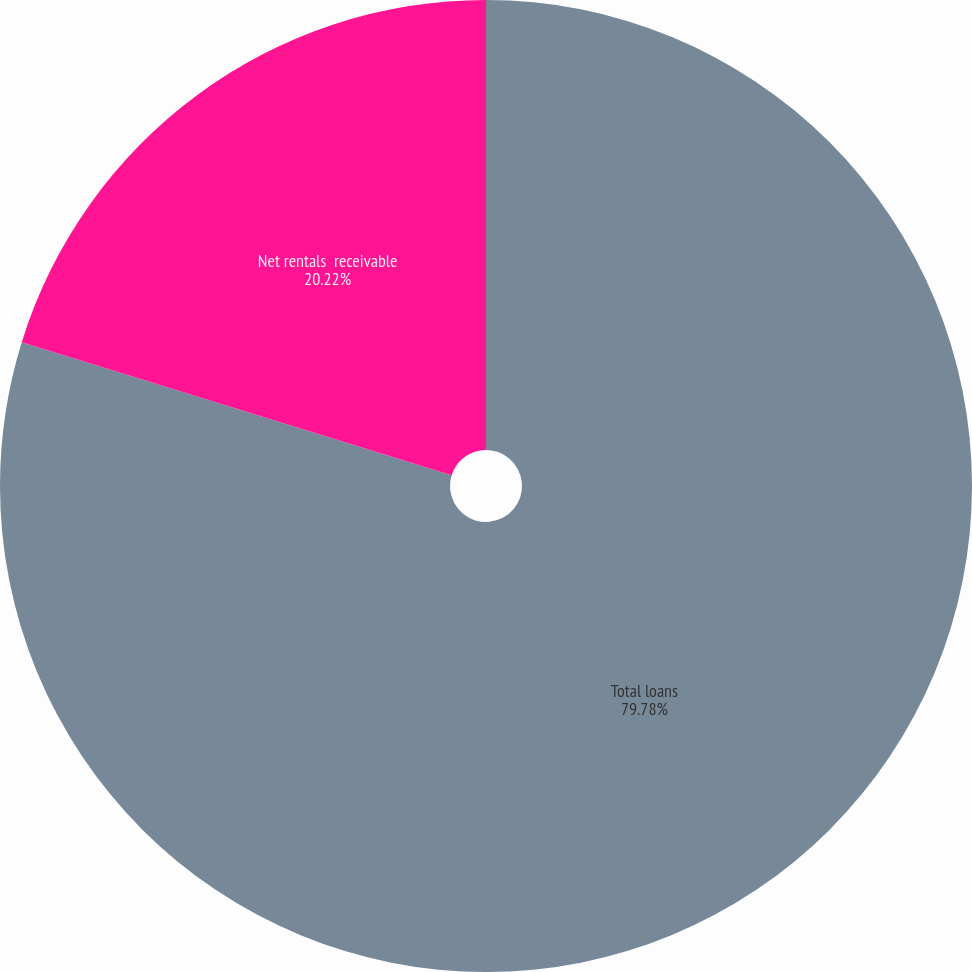Convert chart. <chart><loc_0><loc_0><loc_500><loc_500><pie_chart><fcel>Total loans<fcel>Net rentals  receivable<nl><fcel>79.78%<fcel>20.22%<nl></chart> 